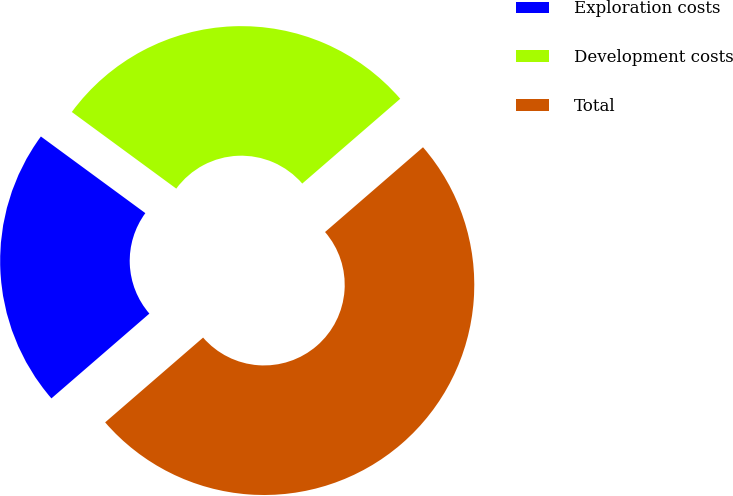Convert chart. <chart><loc_0><loc_0><loc_500><loc_500><pie_chart><fcel>Exploration costs<fcel>Development costs<fcel>Total<nl><fcel>21.43%<fcel>28.57%<fcel>50.0%<nl></chart> 